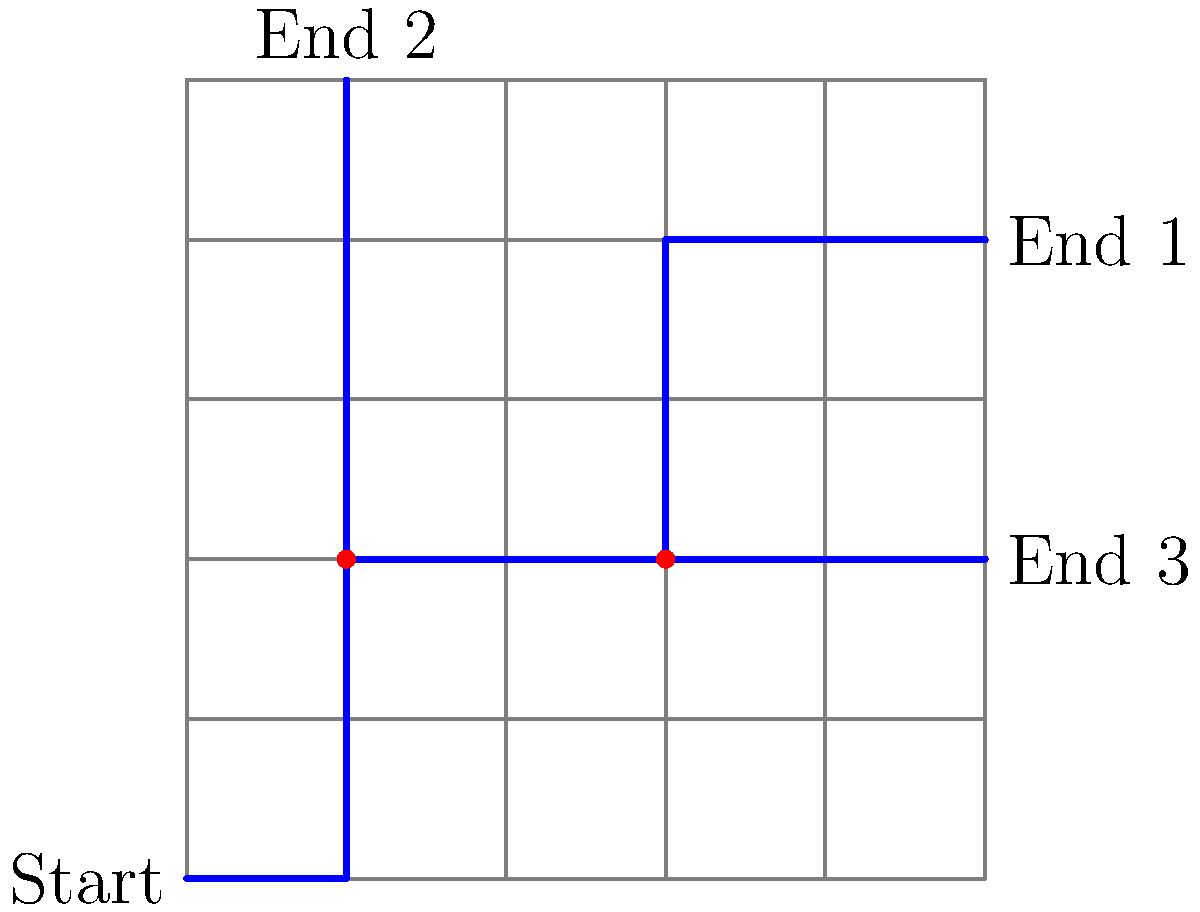In the given train track layout, what is the minimum number of switches required to allow a train to reach all three end points from the start point? To solve this problem, let's analyze the track layout step-by-step:

1. The layout has one start point and three end points.
2. There are two branch points in the track where switches could be placed.
3. Let's examine each branch point:
   a. At (1,2), the track splits into two directions: upward and rightward.
   b. At (3,2), the track splits into two directions: upward and rightward.

4. To reach End 1 (5,4), we need the switch at (3,2) to be set to the upward direction.
5. To reach End 2 (1,5), we need the switch at (1,2) to be set to the upward direction.
6. To reach End 3 (5,2), we need:
   a. The switch at (1,2) to be set to the rightward direction.
   b. The switch at (3,2) to be set to the rightward direction.

7. We can conclude that both branch points require switches to allow access to all three end points.

Therefore, the minimum number of switches required is 2, one at each branch point (1,2) and (3,2).
Answer: 2 switches 